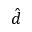Convert formula to latex. <formula><loc_0><loc_0><loc_500><loc_500>\hat { d }</formula> 